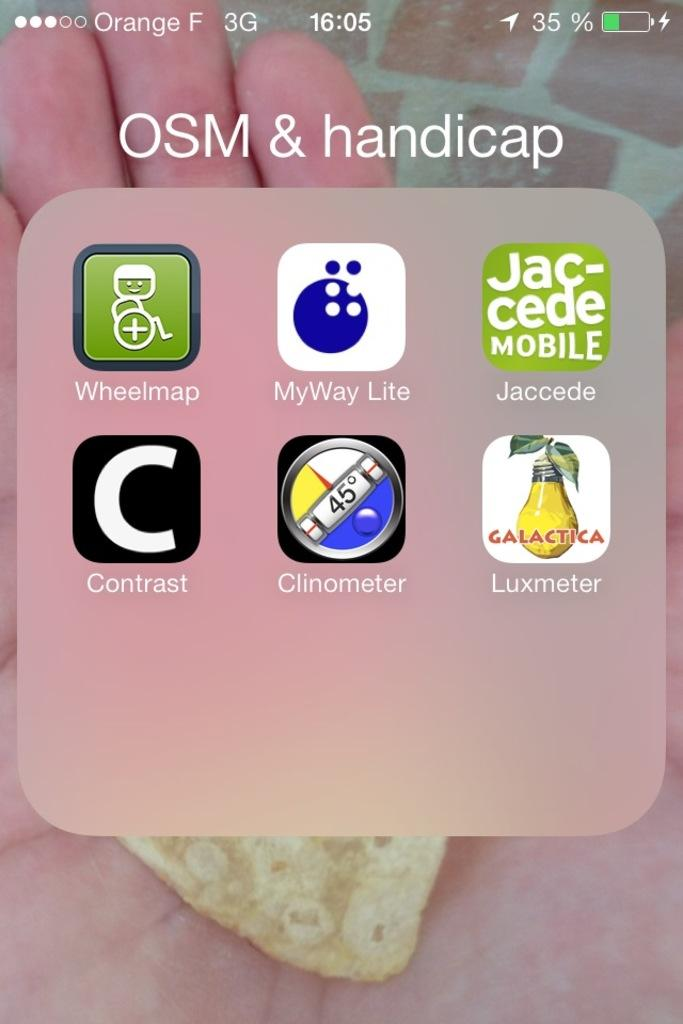<image>
Share a concise interpretation of the image provided. A phone screen shows OSM & handicap apps and only has 35% battery right now. 